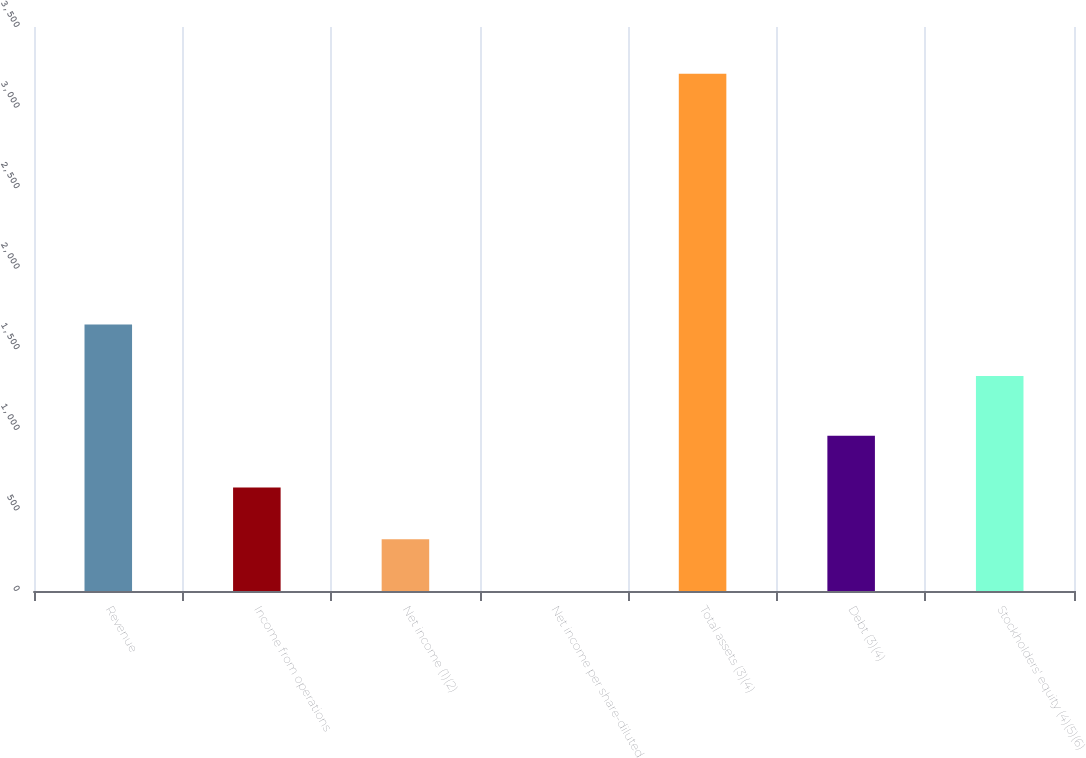Convert chart. <chart><loc_0><loc_0><loc_500><loc_500><bar_chart><fcel>Revenue<fcel>Income from operations<fcel>Net income (1)(2)<fcel>Net income per share-diluted<fcel>Total assets (3)(4)<fcel>Debt (3)(4)<fcel>Stockholders' equity (4)(5)(6)<nl><fcel>1654.51<fcel>642.34<fcel>321.43<fcel>0.52<fcel>3209.6<fcel>963.25<fcel>1333.6<nl></chart> 